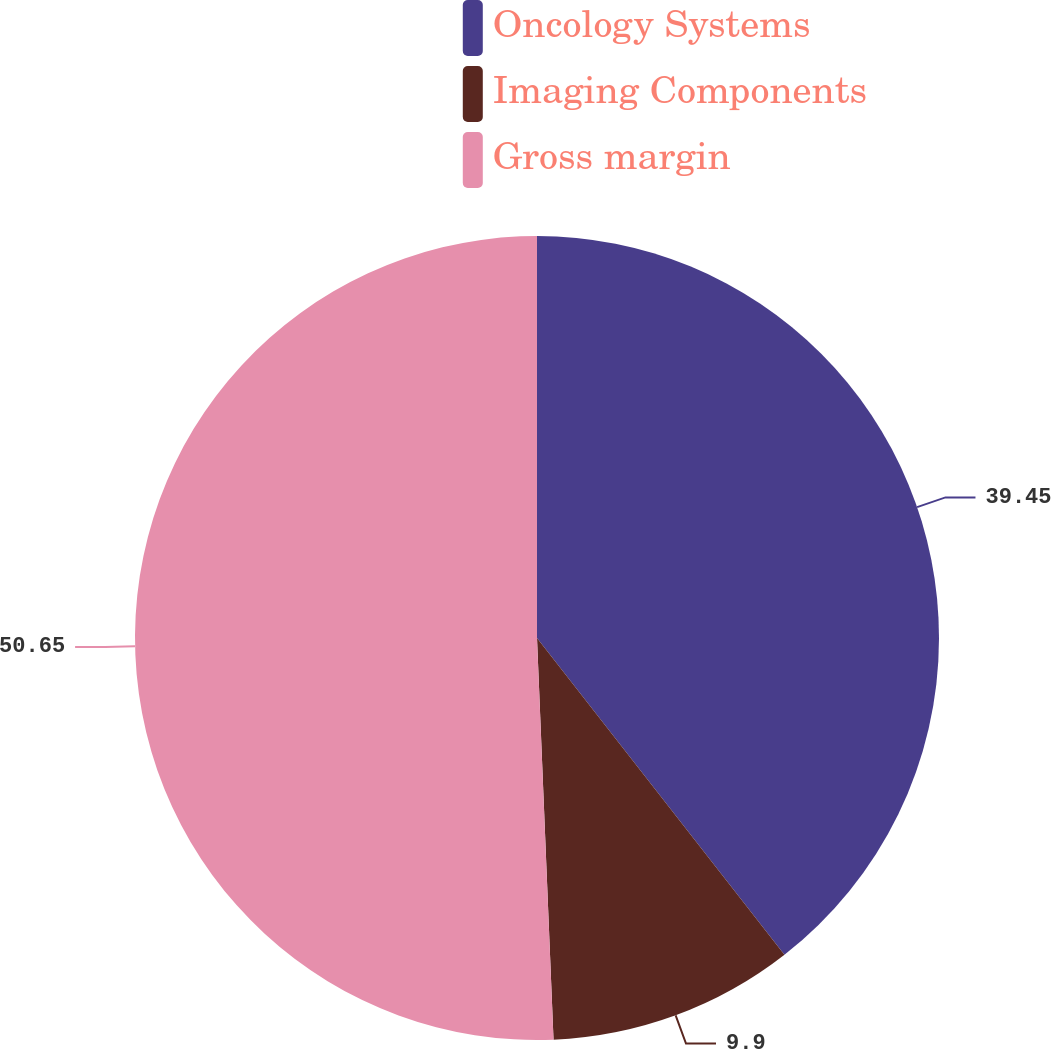<chart> <loc_0><loc_0><loc_500><loc_500><pie_chart><fcel>Oncology Systems<fcel>Imaging Components<fcel>Gross margin<nl><fcel>39.45%<fcel>9.9%<fcel>50.66%<nl></chart> 